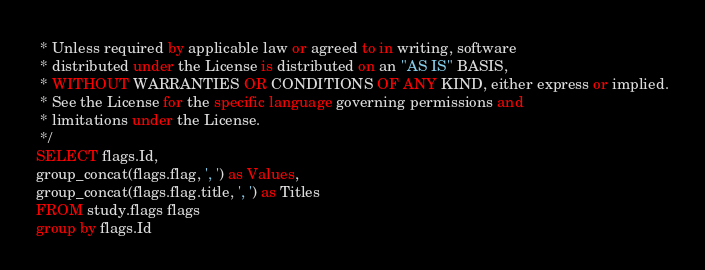Convert code to text. <code><loc_0><loc_0><loc_500><loc_500><_SQL_> * Unless required by applicable law or agreed to in writing, software
 * distributed under the License is distributed on an "AS IS" BASIS,
 * WITHOUT WARRANTIES OR CONDITIONS OF ANY KIND, either express or implied.
 * See the License for the specific language governing permissions and
 * limitations under the License.
 */
SELECT flags.Id,
group_concat(flags.flag, ', ') as Values,
group_concat(flags.flag.title, ', ') as Titles
FROM study.flags flags
group by flags.Id</code> 